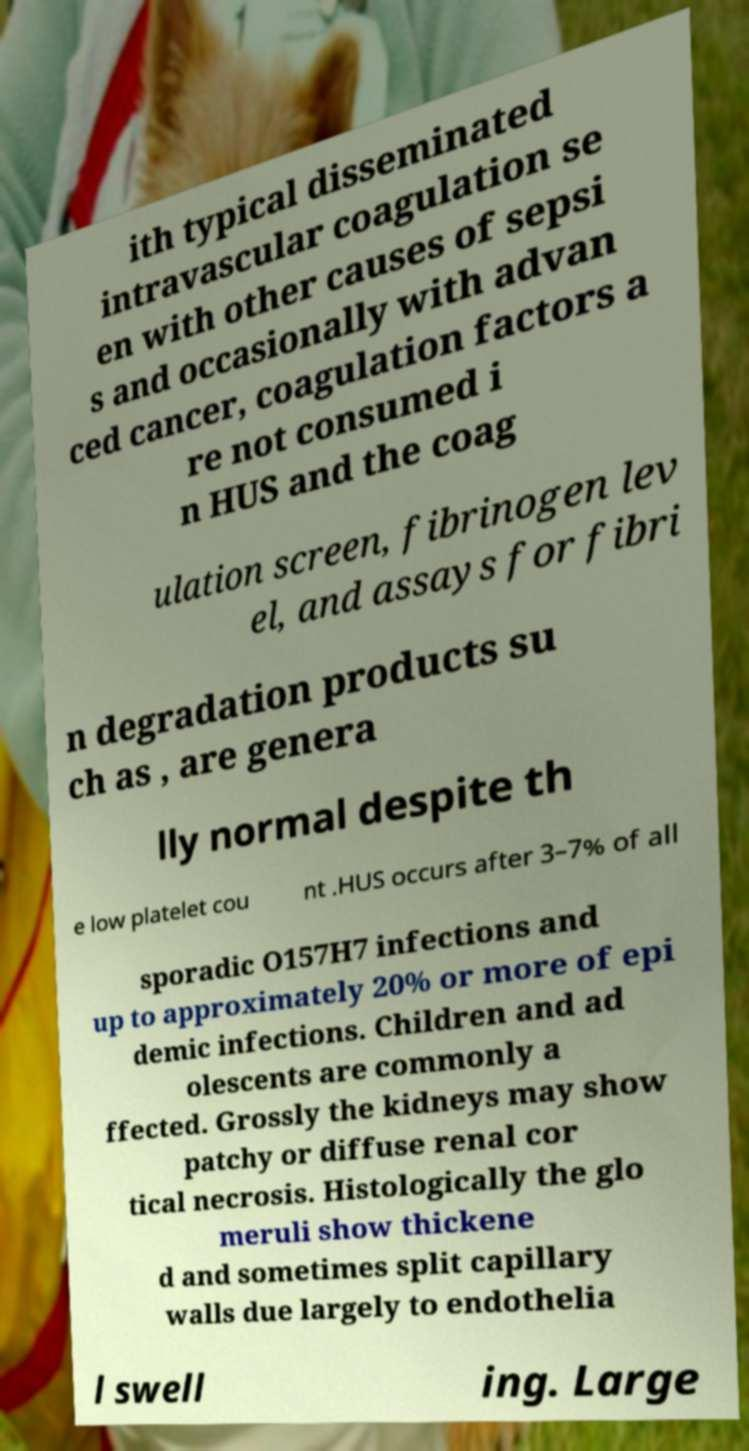I need the written content from this picture converted into text. Can you do that? ith typical disseminated intravascular coagulation se en with other causes of sepsi s and occasionally with advan ced cancer, coagulation factors a re not consumed i n HUS and the coag ulation screen, fibrinogen lev el, and assays for fibri n degradation products su ch as , are genera lly normal despite th e low platelet cou nt .HUS occurs after 3–7% of all sporadic O157H7 infections and up to approximately 20% or more of epi demic infections. Children and ad olescents are commonly a ffected. Grossly the kidneys may show patchy or diffuse renal cor tical necrosis. Histologically the glo meruli show thickene d and sometimes split capillary walls due largely to endothelia l swell ing. Large 